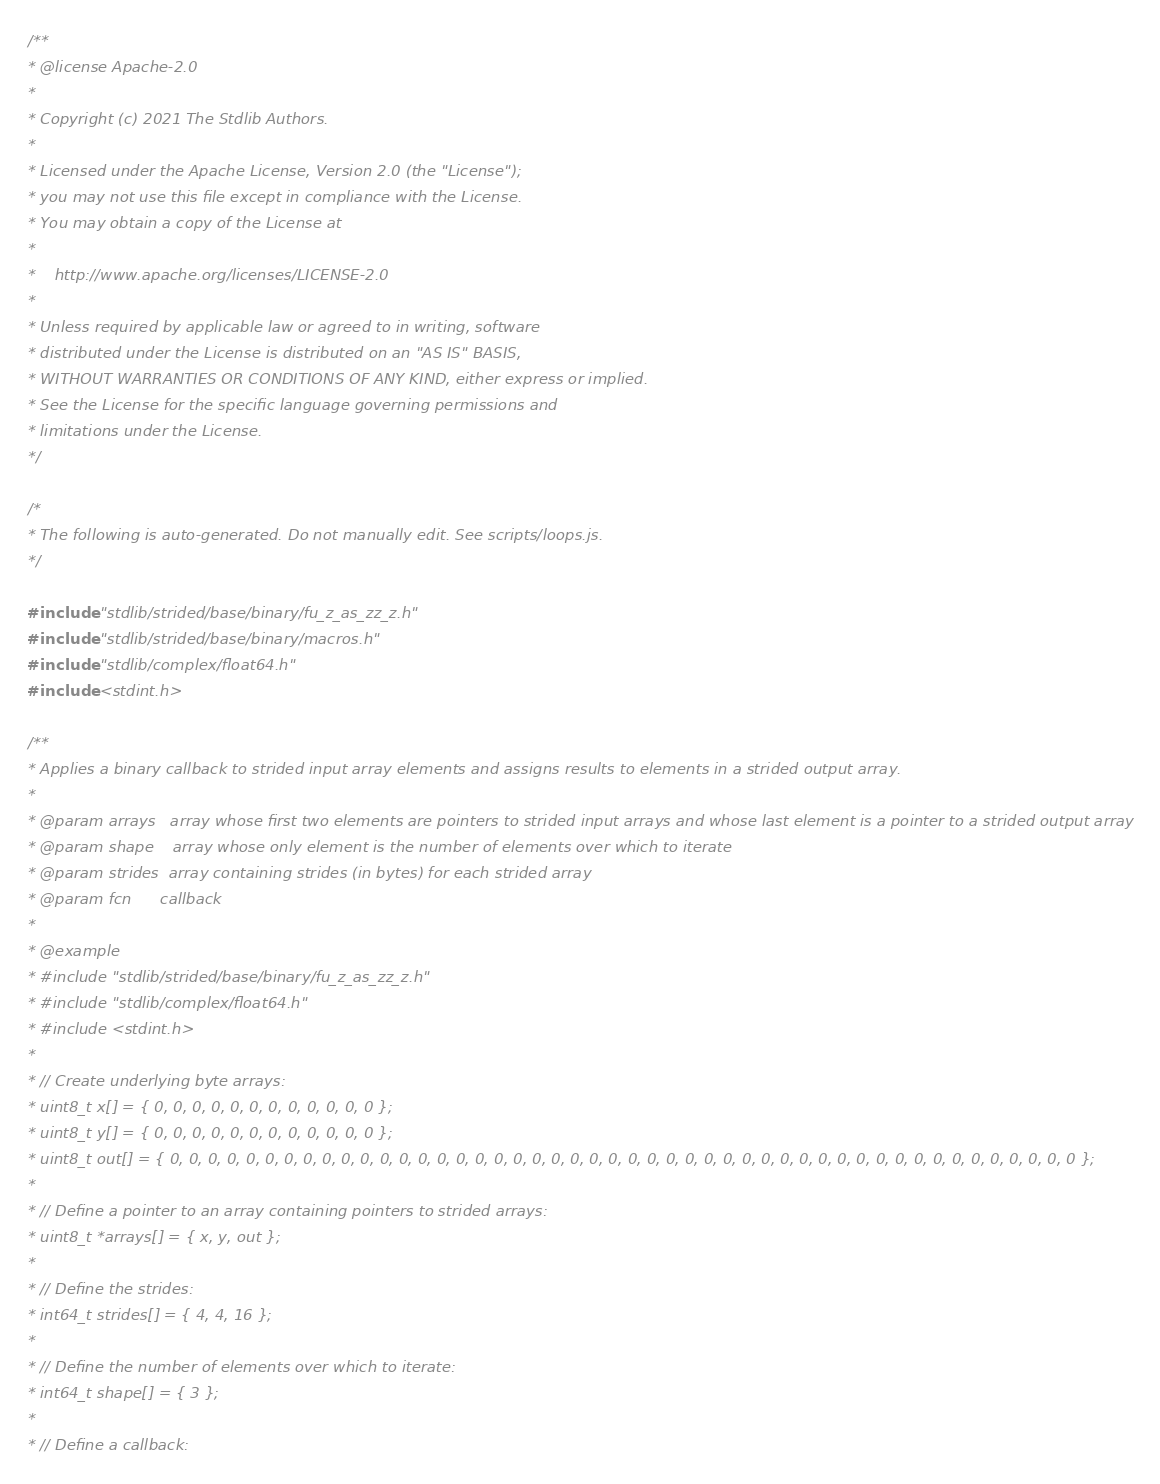<code> <loc_0><loc_0><loc_500><loc_500><_C_>/**
* @license Apache-2.0
*
* Copyright (c) 2021 The Stdlib Authors.
*
* Licensed under the Apache License, Version 2.0 (the "License");
* you may not use this file except in compliance with the License.
* You may obtain a copy of the License at
*
*    http://www.apache.org/licenses/LICENSE-2.0
*
* Unless required by applicable law or agreed to in writing, software
* distributed under the License is distributed on an "AS IS" BASIS,
* WITHOUT WARRANTIES OR CONDITIONS OF ANY KIND, either express or implied.
* See the License for the specific language governing permissions and
* limitations under the License.
*/

/*
* The following is auto-generated. Do not manually edit. See scripts/loops.js.
*/

#include "stdlib/strided/base/binary/fu_z_as_zz_z.h"
#include "stdlib/strided/base/binary/macros.h"
#include "stdlib/complex/float64.h"
#include <stdint.h>

/**
* Applies a binary callback to strided input array elements and assigns results to elements in a strided output array.
*
* @param arrays   array whose first two elements are pointers to strided input arrays and whose last element is a pointer to a strided output array
* @param shape    array whose only element is the number of elements over which to iterate
* @param strides  array containing strides (in bytes) for each strided array
* @param fcn      callback
*
* @example
* #include "stdlib/strided/base/binary/fu_z_as_zz_z.h"
* #include "stdlib/complex/float64.h"
* #include <stdint.h>
*
* // Create underlying byte arrays:
* uint8_t x[] = { 0, 0, 0, 0, 0, 0, 0, 0, 0, 0, 0, 0 };
* uint8_t y[] = { 0, 0, 0, 0, 0, 0, 0, 0, 0, 0, 0, 0 };
* uint8_t out[] = { 0, 0, 0, 0, 0, 0, 0, 0, 0, 0, 0, 0, 0, 0, 0, 0, 0, 0, 0, 0, 0, 0, 0, 0, 0, 0, 0, 0, 0, 0, 0, 0, 0, 0, 0, 0, 0, 0, 0, 0, 0, 0, 0, 0, 0, 0, 0, 0 };
*
* // Define a pointer to an array containing pointers to strided arrays:
* uint8_t *arrays[] = { x, y, out };
*
* // Define the strides:
* int64_t strides[] = { 4, 4, 16 };
*
* // Define the number of elements over which to iterate:
* int64_t shape[] = { 3 };
*
* // Define a callback:</code> 